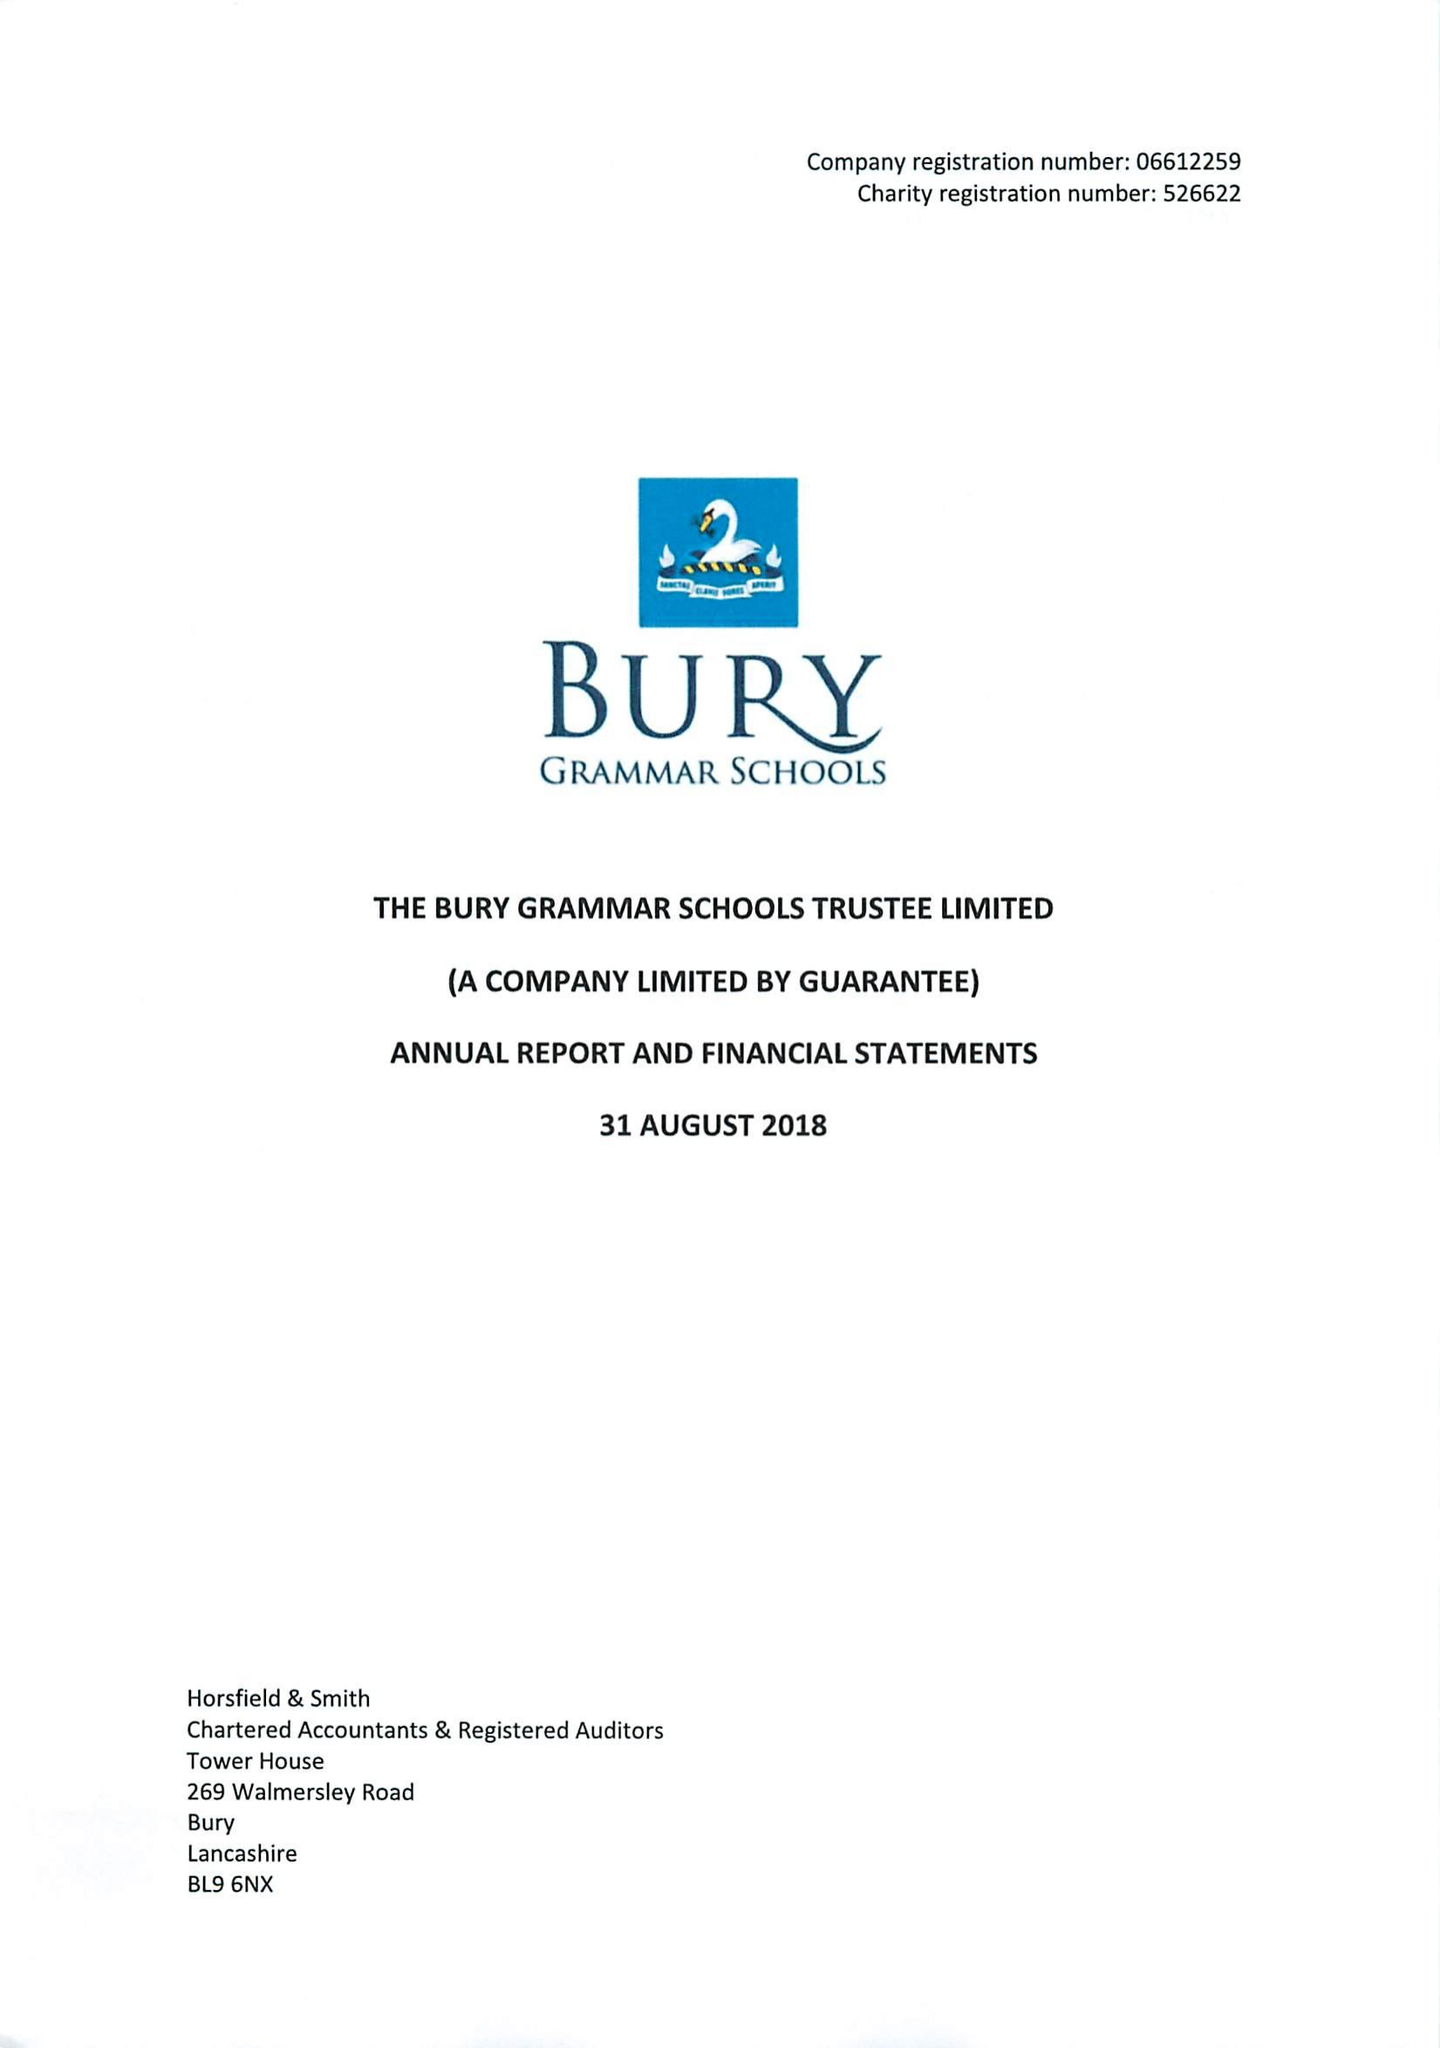What is the value for the address__postcode?
Answer the question using a single word or phrase. BL9 0HG 